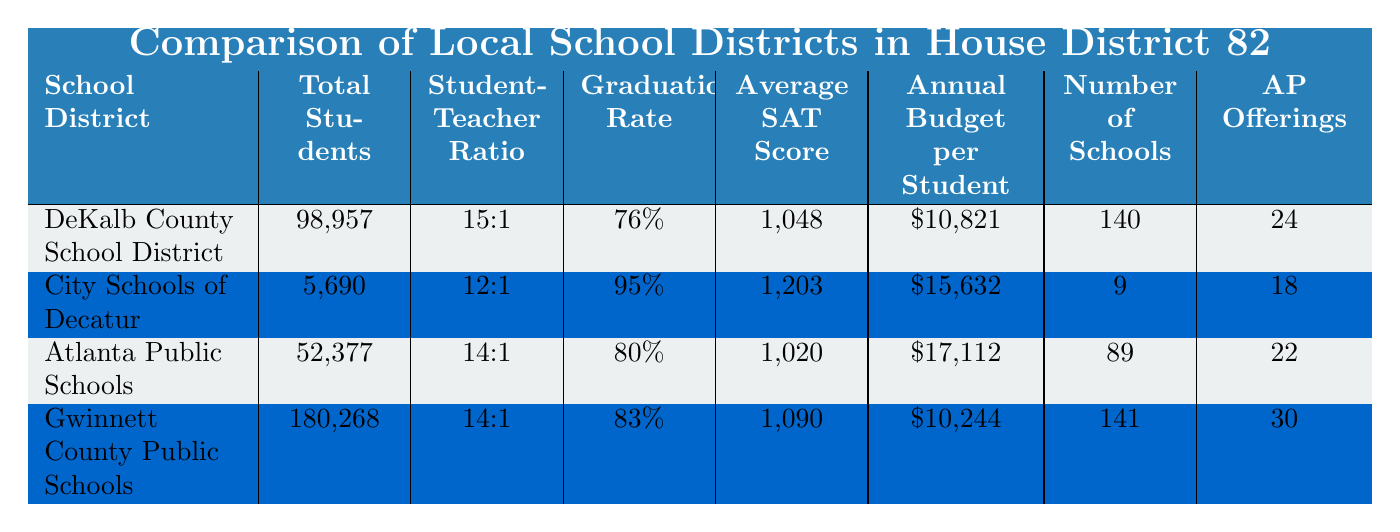What is the total number of students in Gwinnett County Public Schools? The total number of students in the Gwinnett County Public Schools row is clearly indicated in the "Total Students" column as 180,268.
Answer: 180,268 Which school district has the highest graduation rate? By comparing the graduation rates listed in the table, City Schools of Decatur has a graduation rate of 95%, which is higher than the other districts: DeKalb County (76%), Atlanta Public Schools (80%), and Gwinnett County (83%).
Answer: City Schools of Decatur What is the average SAT score for Atlanta Public Schools? Referring to the "Average SAT Score" column, Atlanta Public Schools has an average SAT score of 1,020 listed in the respective row.
Answer: 1,020 How many schools are there in total across all the districts? To find the total number of schools across all districts, add the values from the "Number of Schools" column: 140 + 9 + 89 + 141 = 379.
Answer: 379 Does Gwinnett County Public Schools have a higher average budget per student than the City Schools of Decatur? Comparing the "Annual Budget per Student" values, Gwinnett County ($10,244) does not have a higher average than City Schools of Decatur ($15,632), which confirms the statement is false.
Answer: No What is the student-teacher ratio for DeKalb County School District and Atlanta Public Schools? The "Student-Teacher Ratio" column shows DeKalb County School District has a ratio of 15:1 while Atlanta Public Schools has a ratio of 14:1. These comparisons indicate DeKalb has a slightly higher ratio than Atlanta.
Answer: DeKalb: 15:1, Atlanta: 14:1 How many Advanced Placement offerings does Gwinnett County Public Schools provide? The number of Advanced Placement offerings is stated in the "AP Offerings" column for Gwinnett County Public Schools, which is 30.
Answer: 30 What is the difference between the average SAT scores of City Schools of Decatur and Atlanta Public Schools? The average SAT score for City Schools of Decatur is 1,203, while Atlanta Public Schools has a score of 1,020. The difference is calculated as 1,203 - 1,020 = 183.
Answer: 183 